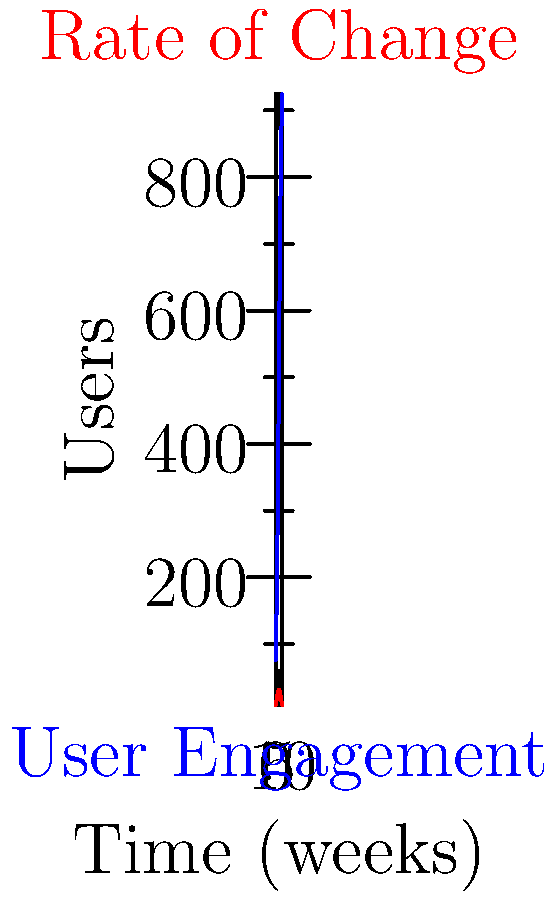As a UX designer analyzing user engagement data, you're presented with a graph showing user engagement over time (blue curve) and its rate of change (red curve). At which point in time does the rate of change in user engagement reach its maximum value, and what does this imply about the user interface's effectiveness? To solve this problem, we need to analyze the rate of change curve (red) and understand its implications:

1. The rate of change curve represents the first derivative of the user engagement function.
2. The maximum point of the rate of change curve occurs at the inflection point of the user engagement curve.
3. From the graph, we can see that the rate of change curve peaks at approximately 5 weeks.
4. At this point, the user engagement curve has its steepest slope, indicating the fastest growth in user adoption.
5. In terms of UX design, this implies that:
   a) The interface changes or improvements made around the 5-week mark were highly effective.
   b) User learning curve and adoption rate were optimal at this point.
   c) The design achieved a balance between novelty and usability, maximizing new user acquisition.
6. After this peak, the rate of change decreases, suggesting:
   a) The user base is stabilizing.
   b) Further significant gains in engagement may require new features or design iterations.

This analysis aligns with the functional programming paradigm of Haskell, where we treat the engagement data as a pure function of time, allowing for clear and concise reasoning about its behavior.
Answer: 5 weeks; optimal interface effectiveness and user adoption rate 